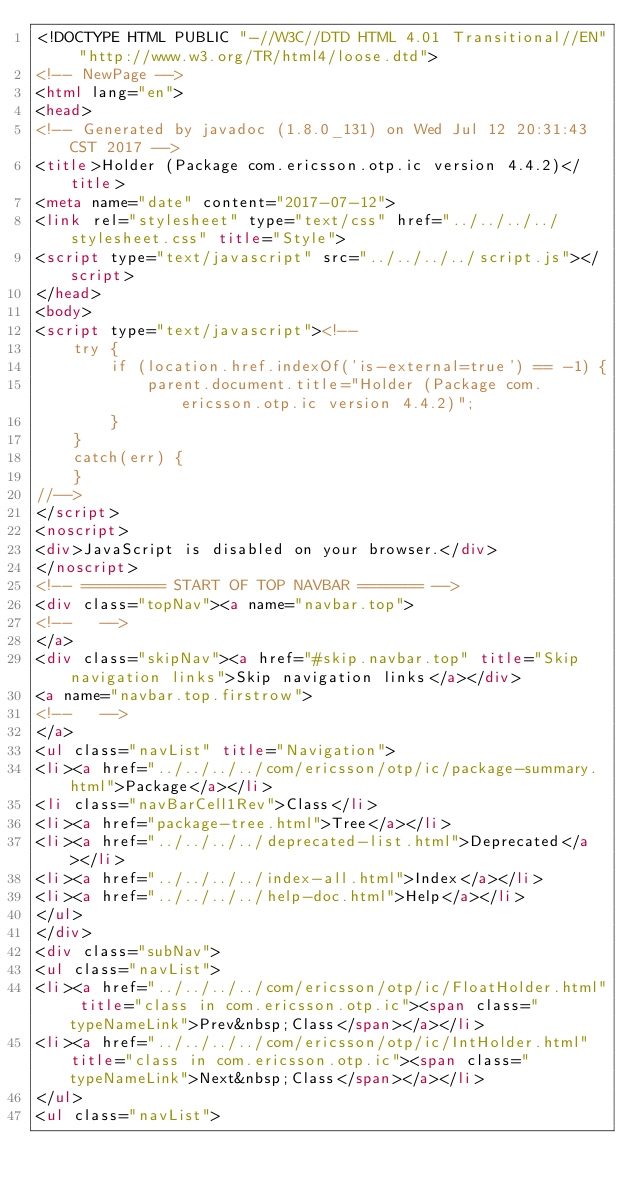Convert code to text. <code><loc_0><loc_0><loc_500><loc_500><_HTML_><!DOCTYPE HTML PUBLIC "-//W3C//DTD HTML 4.01 Transitional//EN" "http://www.w3.org/TR/html4/loose.dtd">
<!-- NewPage -->
<html lang="en">
<head>
<!-- Generated by javadoc (1.8.0_131) on Wed Jul 12 20:31:43 CST 2017 -->
<title>Holder (Package com.ericsson.otp.ic version 4.4.2)</title>
<meta name="date" content="2017-07-12">
<link rel="stylesheet" type="text/css" href="../../../../stylesheet.css" title="Style">
<script type="text/javascript" src="../../../../script.js"></script>
</head>
<body>
<script type="text/javascript"><!--
    try {
        if (location.href.indexOf('is-external=true') == -1) {
            parent.document.title="Holder (Package com.ericsson.otp.ic version 4.4.2)";
        }
    }
    catch(err) {
    }
//-->
</script>
<noscript>
<div>JavaScript is disabled on your browser.</div>
</noscript>
<!-- ========= START OF TOP NAVBAR ======= -->
<div class="topNav"><a name="navbar.top">
<!--   -->
</a>
<div class="skipNav"><a href="#skip.navbar.top" title="Skip navigation links">Skip navigation links</a></div>
<a name="navbar.top.firstrow">
<!--   -->
</a>
<ul class="navList" title="Navigation">
<li><a href="../../../../com/ericsson/otp/ic/package-summary.html">Package</a></li>
<li class="navBarCell1Rev">Class</li>
<li><a href="package-tree.html">Tree</a></li>
<li><a href="../../../../deprecated-list.html">Deprecated</a></li>
<li><a href="../../../../index-all.html">Index</a></li>
<li><a href="../../../../help-doc.html">Help</a></li>
</ul>
</div>
<div class="subNav">
<ul class="navList">
<li><a href="../../../../com/ericsson/otp/ic/FloatHolder.html" title="class in com.ericsson.otp.ic"><span class="typeNameLink">Prev&nbsp;Class</span></a></li>
<li><a href="../../../../com/ericsson/otp/ic/IntHolder.html" title="class in com.ericsson.otp.ic"><span class="typeNameLink">Next&nbsp;Class</span></a></li>
</ul>
<ul class="navList"></code> 